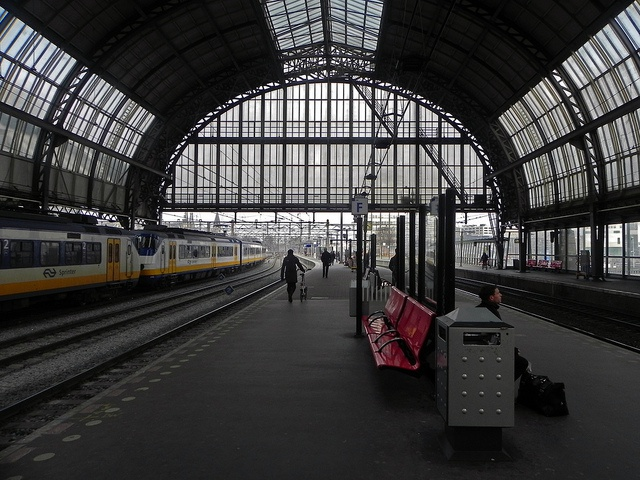Describe the objects in this image and their specific colors. I can see train in black, gray, maroon, and darkgreen tones, bench in black, maroon, and brown tones, suitcase in black tones, bench in black, maroon, brown, and gray tones, and people in black, gray, and darkgray tones in this image. 